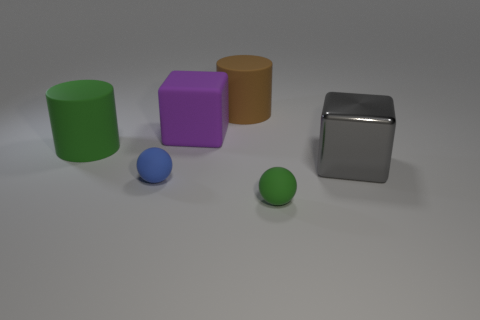Add 4 small blue matte spheres. How many objects exist? 10 Subtract all spheres. How many objects are left? 4 Subtract 0 purple balls. How many objects are left? 6 Subtract all green balls. Subtract all green matte things. How many objects are left? 3 Add 4 tiny matte objects. How many tiny matte objects are left? 6 Add 1 large cyan matte objects. How many large cyan matte objects exist? 1 